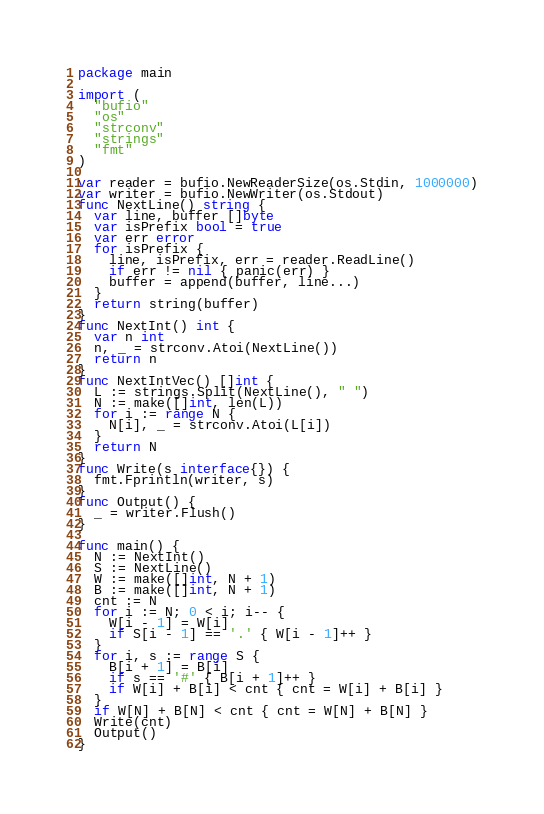Convert code to text. <code><loc_0><loc_0><loc_500><loc_500><_Go_>package main
 
import (
  "bufio"
  "os"
  "strconv"
  "strings"
  "fmt"
)
 
var reader = bufio.NewReaderSize(os.Stdin, 1000000)
var writer = bufio.NewWriter(os.Stdout)
func NextLine() string {
  var line, buffer []byte
  var isPrefix bool = true
  var err error
  for isPrefix {
    line, isPrefix, err = reader.ReadLine()
    if err != nil { panic(err) }
    buffer = append(buffer, line...)
  }
  return string(buffer)
}
func NextInt() int {
  var n int
  n, _ = strconv.Atoi(NextLine())
  return n
}
func NextIntVec() []int {
  L := strings.Split(NextLine(), " ")
  N := make([]int, len(L))
  for i := range N {
    N[i], _ = strconv.Atoi(L[i])
  }
  return N
}
func Write(s interface{}) {
  fmt.Fprintln(writer, s)
}
func Output() {
  _ = writer.Flush()
}

func main() {
  N := NextInt()
  S := NextLine()
  W := make([]int, N + 1)
  B := make([]int, N + 1)
  cnt := N
  for i := N; 0 < i; i-- {
    W[i - 1] = W[i]
    if S[i - 1] == '.' { W[i - 1]++ }
  }
  for i, s := range S {
    B[i + 1] = B[i]
    if s == '#' { B[i + 1]++ }
    if W[i] + B[i] < cnt { cnt = W[i] + B[i] }
  }
  if W[N] + B[N] < cnt { cnt = W[N] + B[N] }
  Write(cnt)
  Output()
}</code> 